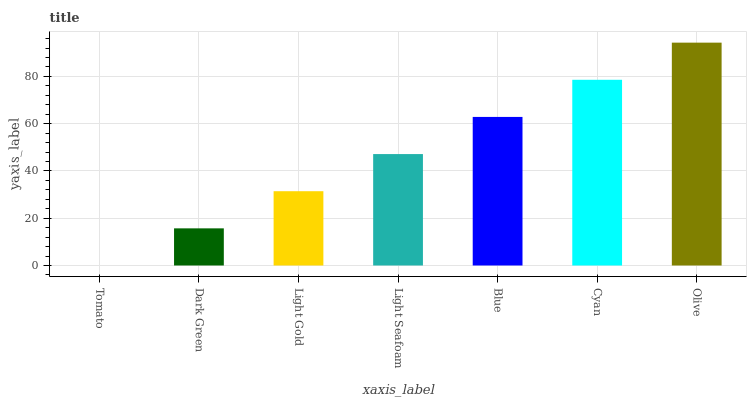Is Tomato the minimum?
Answer yes or no. Yes. Is Olive the maximum?
Answer yes or no. Yes. Is Dark Green the minimum?
Answer yes or no. No. Is Dark Green the maximum?
Answer yes or no. No. Is Dark Green greater than Tomato?
Answer yes or no. Yes. Is Tomato less than Dark Green?
Answer yes or no. Yes. Is Tomato greater than Dark Green?
Answer yes or no. No. Is Dark Green less than Tomato?
Answer yes or no. No. Is Light Seafoam the high median?
Answer yes or no. Yes. Is Light Seafoam the low median?
Answer yes or no. Yes. Is Tomato the high median?
Answer yes or no. No. Is Dark Green the low median?
Answer yes or no. No. 